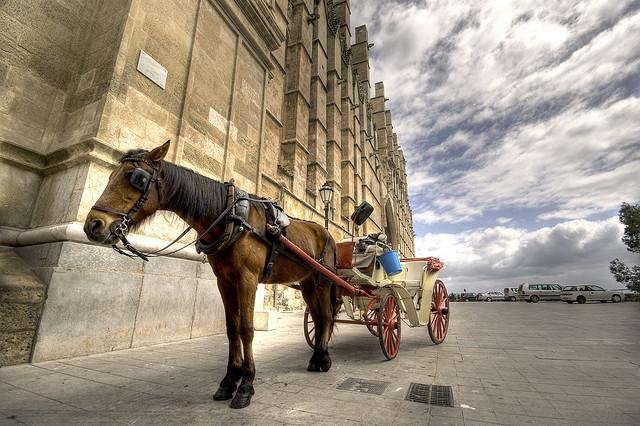This animal is most closely related to what other animal? Please explain your reasoning. donkey. The animal in the picture is a horse.   in looking at its head, ears, mane and feet, it very closely resembles a donkey. 